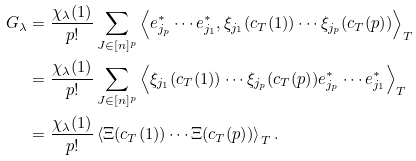<formula> <loc_0><loc_0><loc_500><loc_500>G _ { \lambda } & = \frac { \chi _ { \lambda } ( 1 ) } { p ! } \sum _ { J \in [ n ] ^ { p } } \left < e ^ { * } _ { j _ { p } } \cdots e ^ { * } _ { j _ { 1 } } , \xi _ { j _ { 1 } } ( c _ { T } ( 1 ) ) \cdots \xi _ { j _ { p } } ( c _ { T } ( p ) ) \right > _ { T } \\ & = \frac { \chi _ { \lambda } ( 1 ) } { p ! } \sum _ { J \in [ n ] ^ { p } } \left < \xi _ { j _ { 1 } } ( c _ { T } ( 1 ) ) \cdots \xi _ { j _ { p } } ( c _ { T } ( p ) ) e ^ { * } _ { j _ { p } } \cdots e ^ { * } _ { j _ { 1 } } \right > _ { T } \\ & = \frac { \chi _ { \lambda } ( 1 ) } { p ! } \left < \Xi ( c _ { T } ( 1 ) ) \cdots \Xi ( c _ { T } ( p ) ) \right > _ { T } .</formula> 